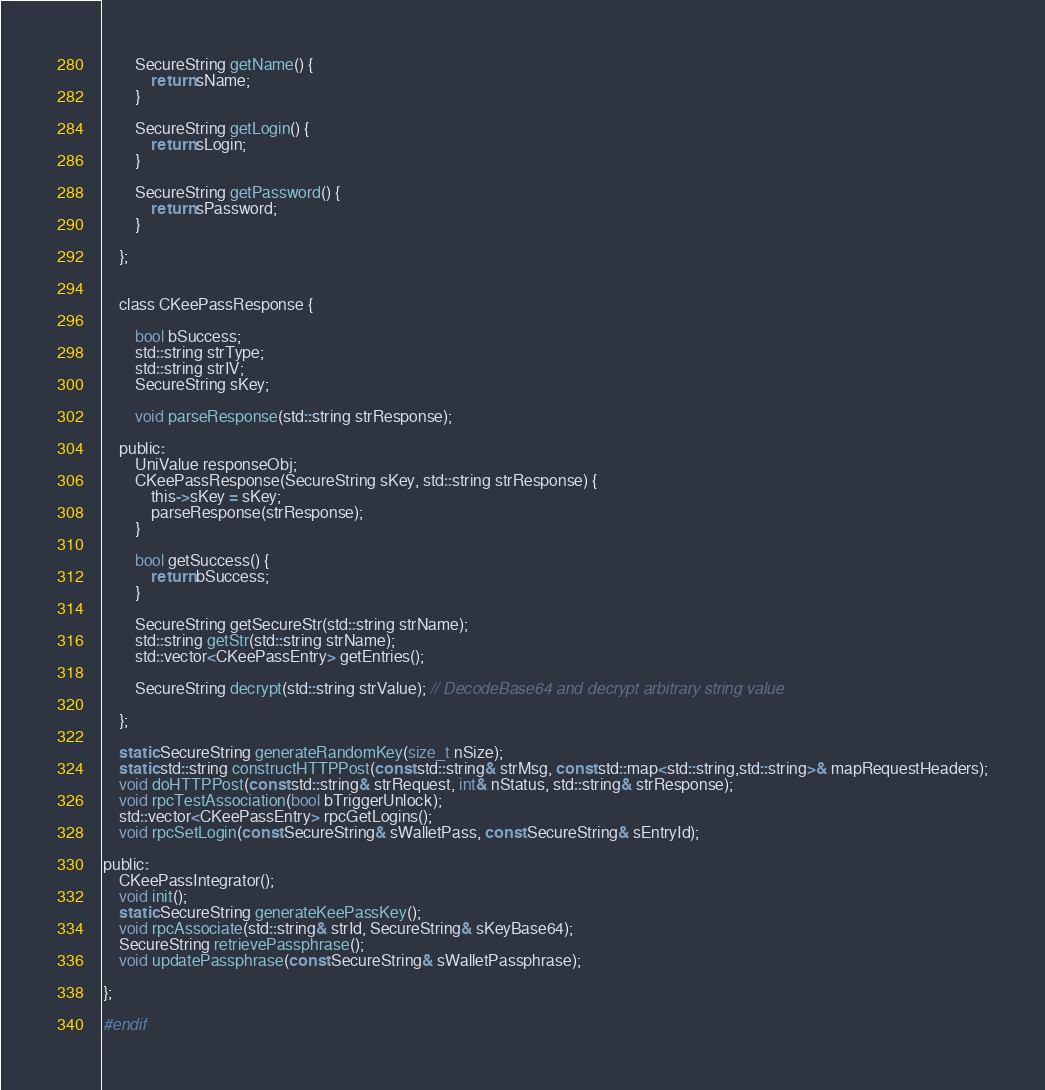<code> <loc_0><loc_0><loc_500><loc_500><_C_>
        SecureString getName() {
            return sName;
        }

        SecureString getLogin() {
            return sLogin;
        }

        SecureString getPassword() {
            return sPassword;
        }

    };


    class CKeePassResponse {

        bool bSuccess;
        std::string strType;
        std::string strIV;
        SecureString sKey;

        void parseResponse(std::string strResponse);

    public:
        UniValue responseObj;
        CKeePassResponse(SecureString sKey, std::string strResponse) {
            this->sKey = sKey;
            parseResponse(strResponse);
        }

        bool getSuccess() {
            return bSuccess;
        }

        SecureString getSecureStr(std::string strName);
        std::string getStr(std::string strName);
        std::vector<CKeePassEntry> getEntries();

        SecureString decrypt(std::string strValue); // DecodeBase64 and decrypt arbitrary string value

    };

    static SecureString generateRandomKey(size_t nSize);
    static std::string constructHTTPPost(const std::string& strMsg, const std::map<std::string,std::string>& mapRequestHeaders);
    void doHTTPPost(const std::string& strRequest, int& nStatus, std::string& strResponse);
    void rpcTestAssociation(bool bTriggerUnlock);
    std::vector<CKeePassEntry> rpcGetLogins();
    void rpcSetLogin(const SecureString& sWalletPass, const SecureString& sEntryId);

public:
    CKeePassIntegrator();
    void init();
    static SecureString generateKeePassKey();
    void rpcAssociate(std::string& strId, SecureString& sKeyBase64);
    SecureString retrievePassphrase();
    void updatePassphrase(const SecureString& sWalletPassphrase);

};

#endif</code> 